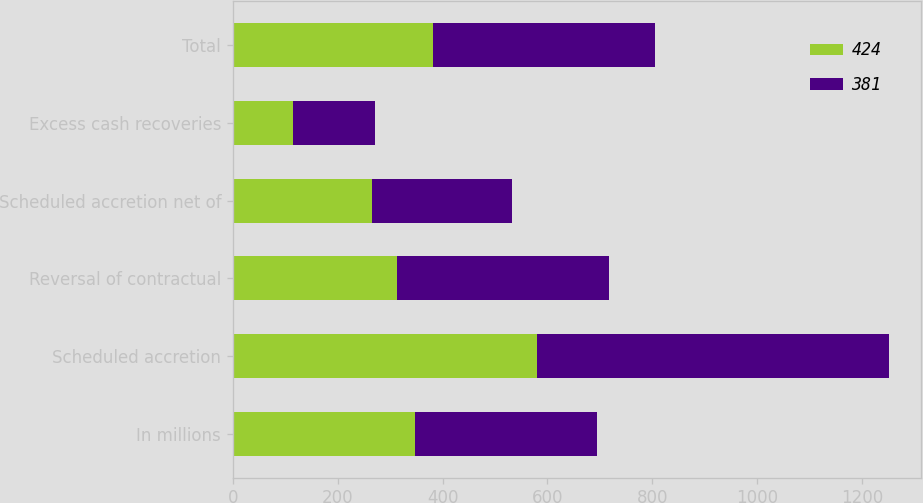Convert chart. <chart><loc_0><loc_0><loc_500><loc_500><stacked_bar_chart><ecel><fcel>In millions<fcel>Scheduled accretion<fcel>Reversal of contractual<fcel>Scheduled accretion net of<fcel>Excess cash recoveries<fcel>Total<nl><fcel>424<fcel>347.5<fcel>580<fcel>314<fcel>266<fcel>115<fcel>381<nl><fcel>381<fcel>347.5<fcel>671<fcel>404<fcel>267<fcel>157<fcel>424<nl></chart> 